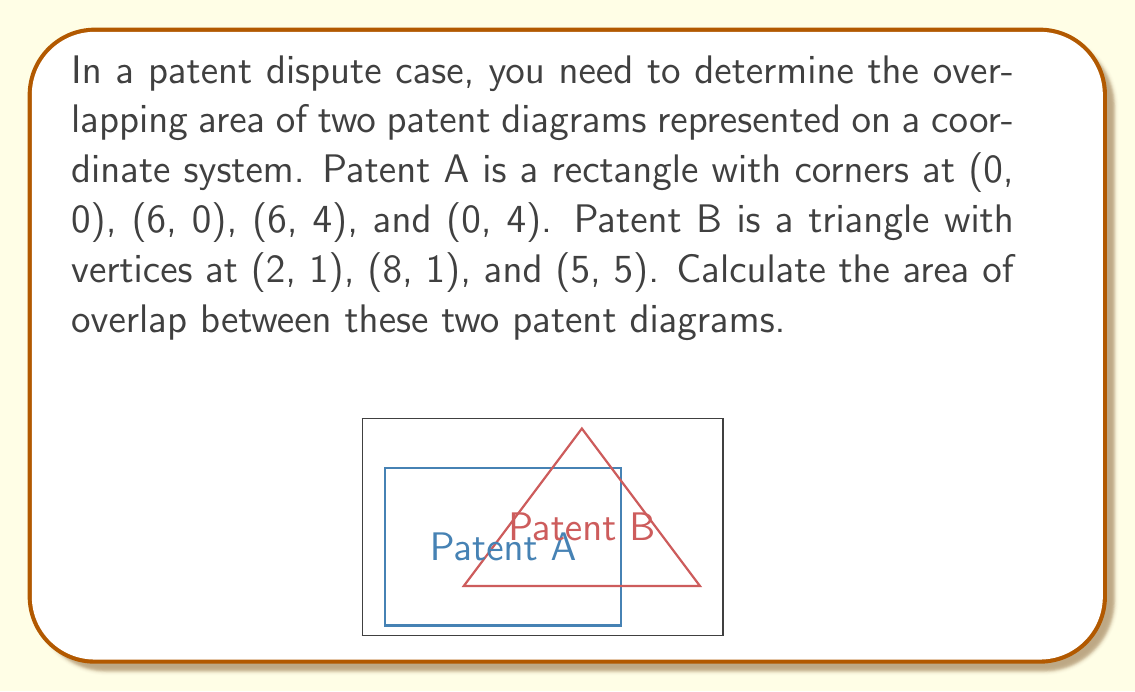Can you solve this math problem? To solve this problem, we need to follow these steps:

1) First, identify the points of intersection between the two shapes.
   - The line y = 1 (bottom of triangle) intersects the rectangle at (2, 1) and (6, 1).
   - The line x = 6 (right side of rectangle) intersects the triangle at (6, 1) and (6, 3).

2) The overlapping region is a quadrilateral with vertices at (2, 1), (6, 1), (6, 3), and (5, 4).

3) We can split this quadrilateral into a rectangle and a triangle:
   - Rectangle: (2, 1) to (6, 3)
   - Triangle: Above the line from (6, 3) to (5, 4)

4) Calculate the area of the rectangle:
   $$A_{rectangle} = 4 * 2 = 8 \text{ square units}$$

5) Calculate the area of the triangle:
   Base = 1, Height = 1
   $$A_{triangle} = \frac{1}{2} * 1 * 1 = 0.5 \text{ square units}$$

6) Sum the areas:
   $$A_{total} = 8 + 0.5 = 8.5 \text{ square units}$$

Therefore, the overlapping area is 8.5 square units.
Answer: 8.5 square units 